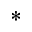<formula> <loc_0><loc_0><loc_500><loc_500>^ { \ast }</formula> 